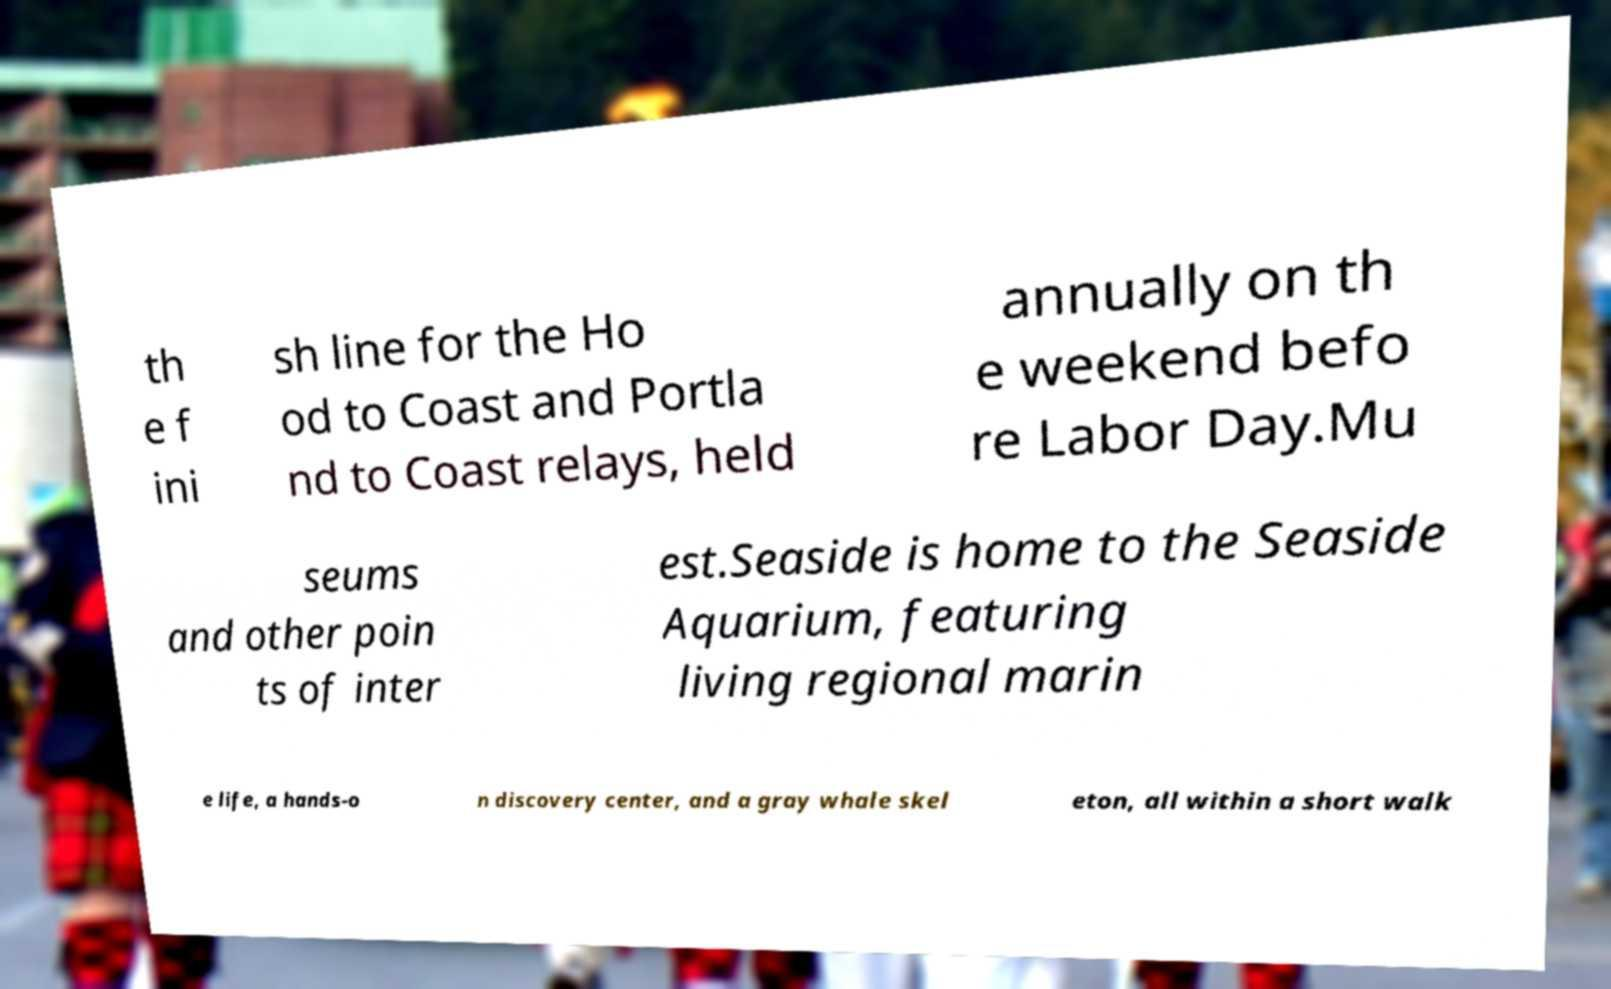For documentation purposes, I need the text within this image transcribed. Could you provide that? th e f ini sh line for the Ho od to Coast and Portla nd to Coast relays, held annually on th e weekend befo re Labor Day.Mu seums and other poin ts of inter est.Seaside is home to the Seaside Aquarium, featuring living regional marin e life, a hands-o n discovery center, and a gray whale skel eton, all within a short walk 